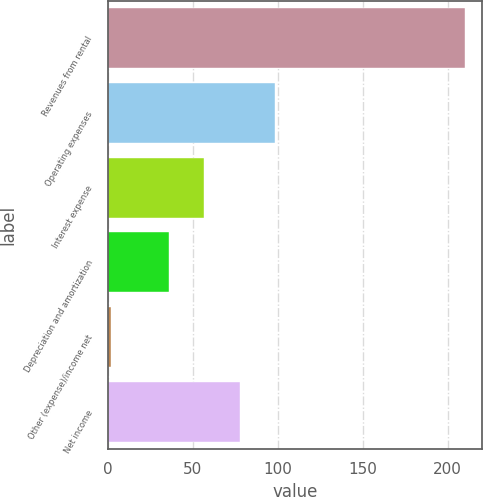<chart> <loc_0><loc_0><loc_500><loc_500><bar_chart><fcel>Revenues from rental<fcel>Operating expenses<fcel>Interest expense<fcel>Depreciation and amortization<fcel>Other (expense)/income net<fcel>Net income<nl><fcel>209.9<fcel>98.43<fcel>56.81<fcel>36<fcel>1.8<fcel>77.62<nl></chart> 